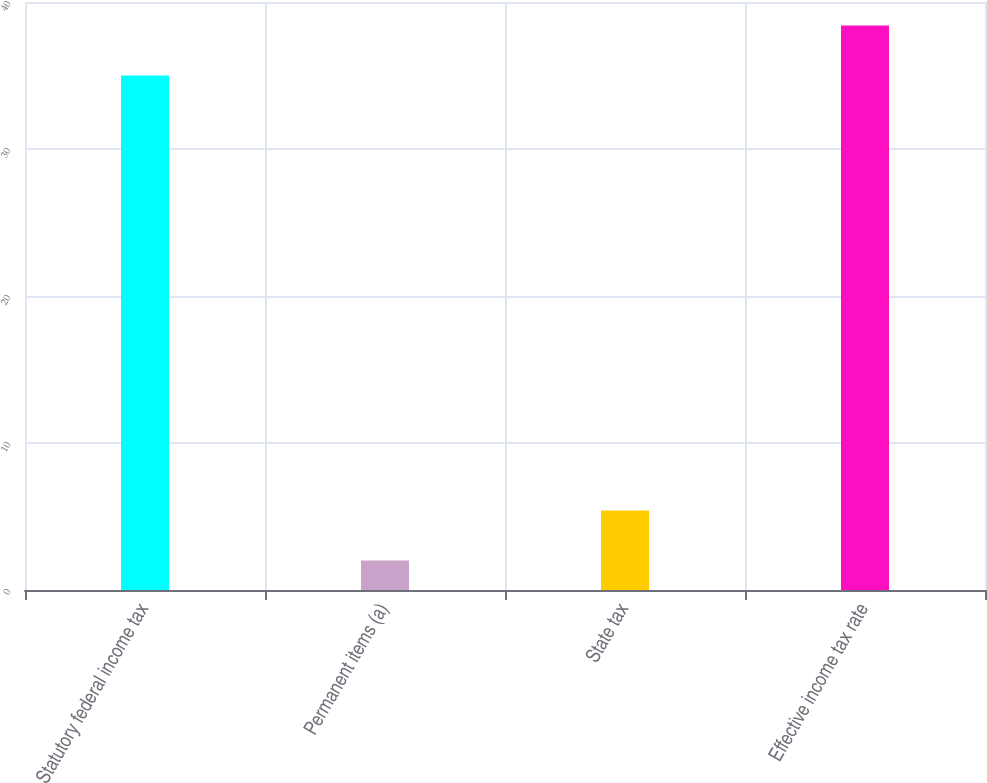Convert chart. <chart><loc_0><loc_0><loc_500><loc_500><bar_chart><fcel>Statutory federal income tax<fcel>Permanent items (a)<fcel>State tax<fcel>Effective income tax rate<nl><fcel>35<fcel>2<fcel>5.4<fcel>38.4<nl></chart> 